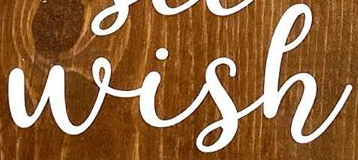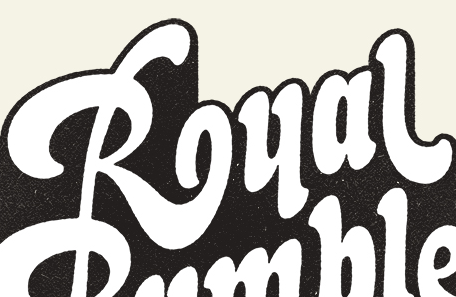Read the text content from these images in order, separated by a semicolon. Wish; Rual 